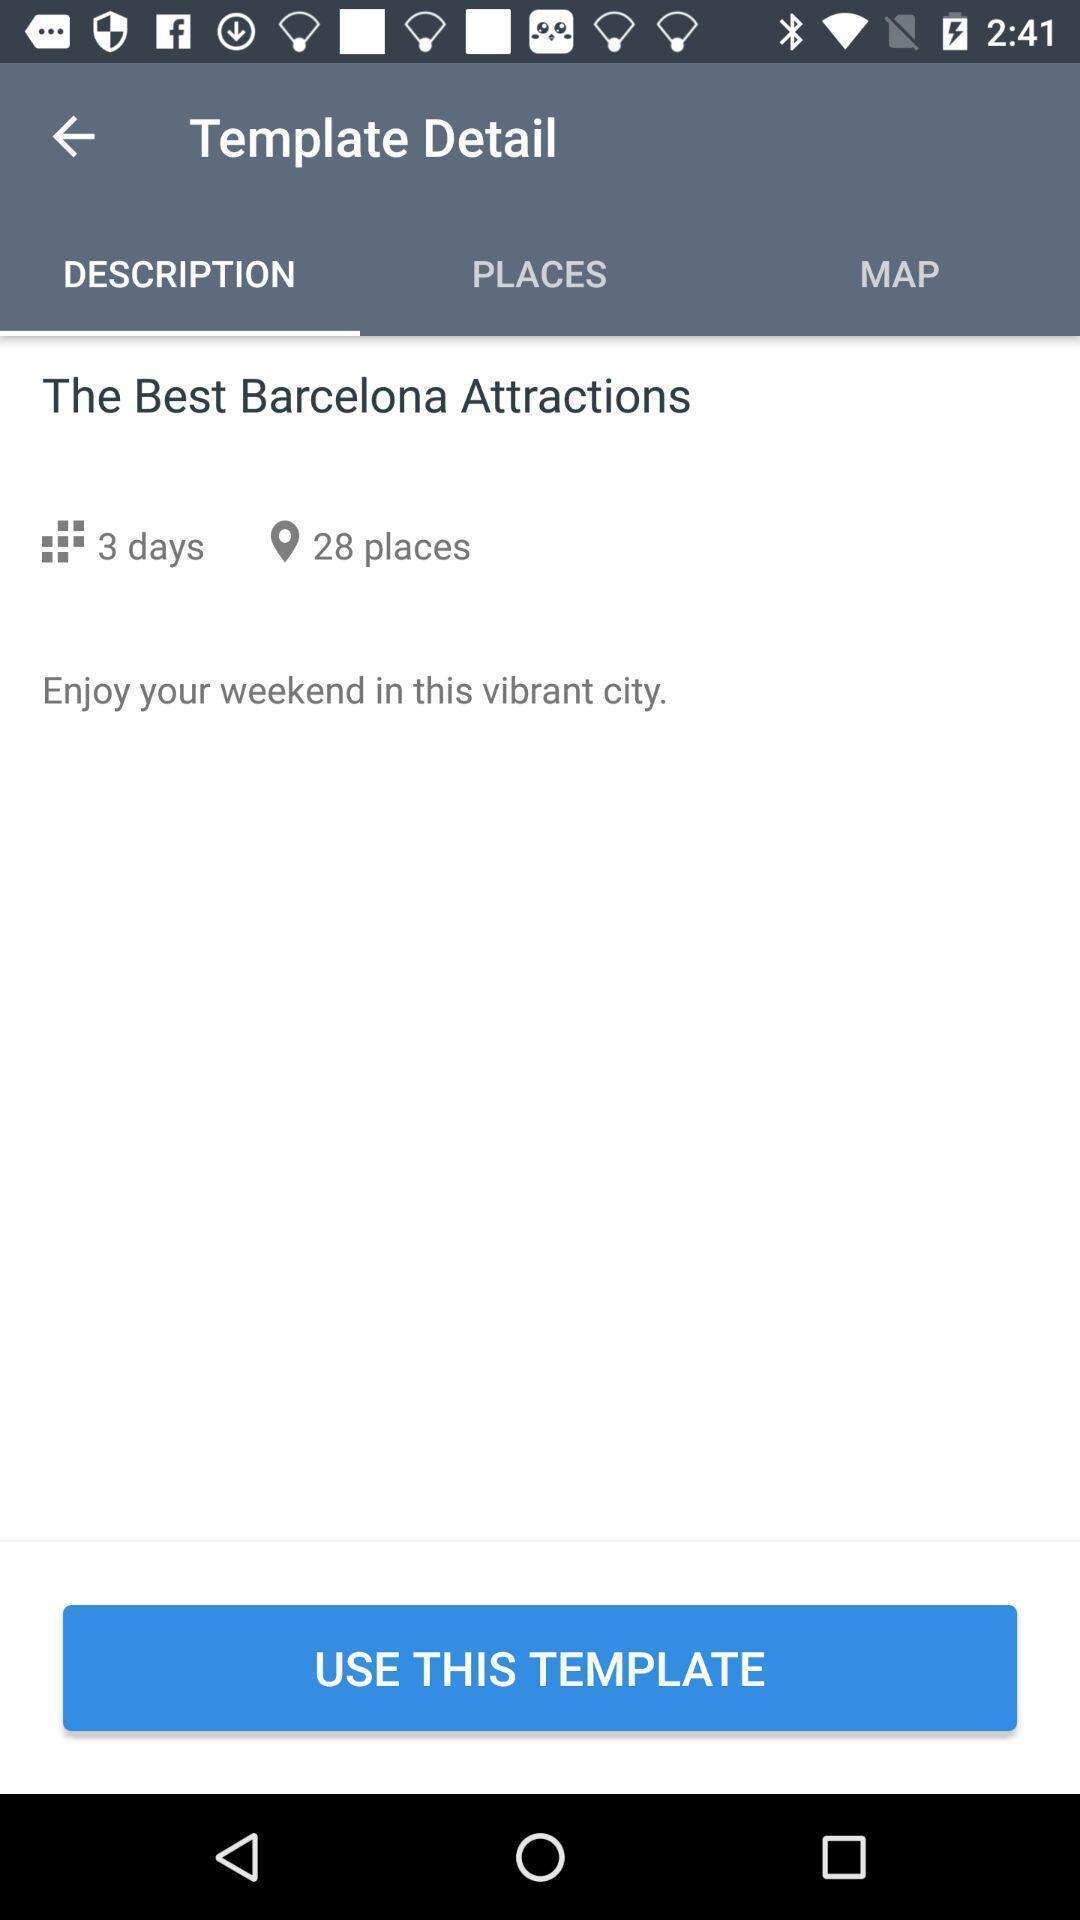Tell me about the visual elements in this screen capture. Page showing template detail in app. 